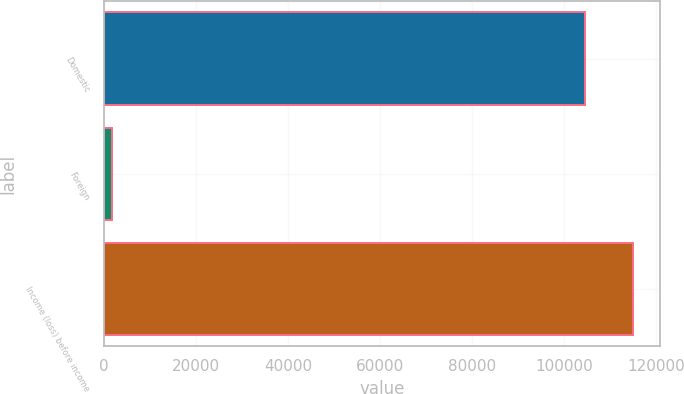<chart> <loc_0><loc_0><loc_500><loc_500><bar_chart><fcel>Domestic<fcel>Foreign<fcel>Income (loss) before income<nl><fcel>104556<fcel>1706<fcel>115012<nl></chart> 